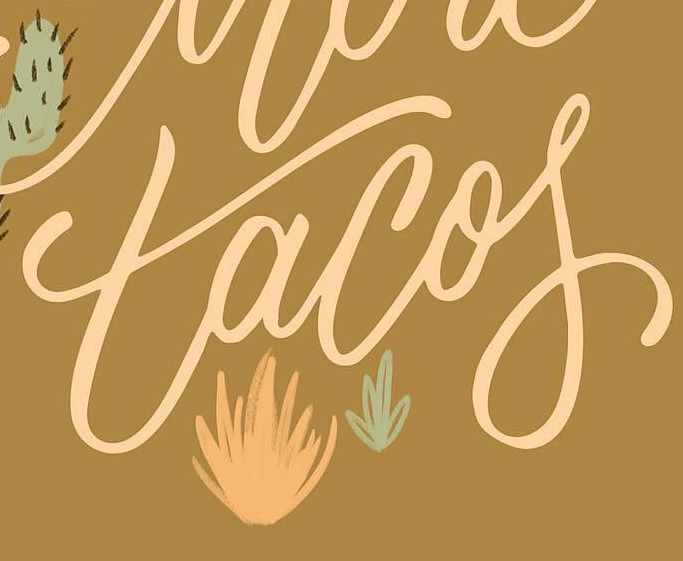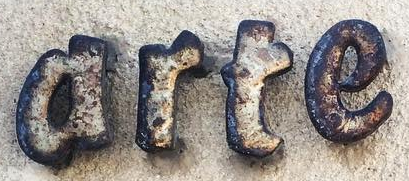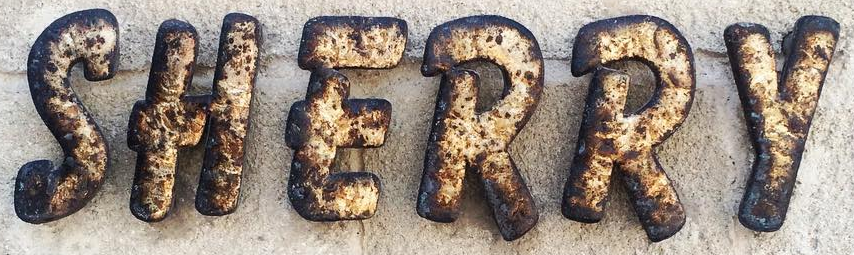Identify the words shown in these images in order, separated by a semicolon. tacof; arte; SHERRY 